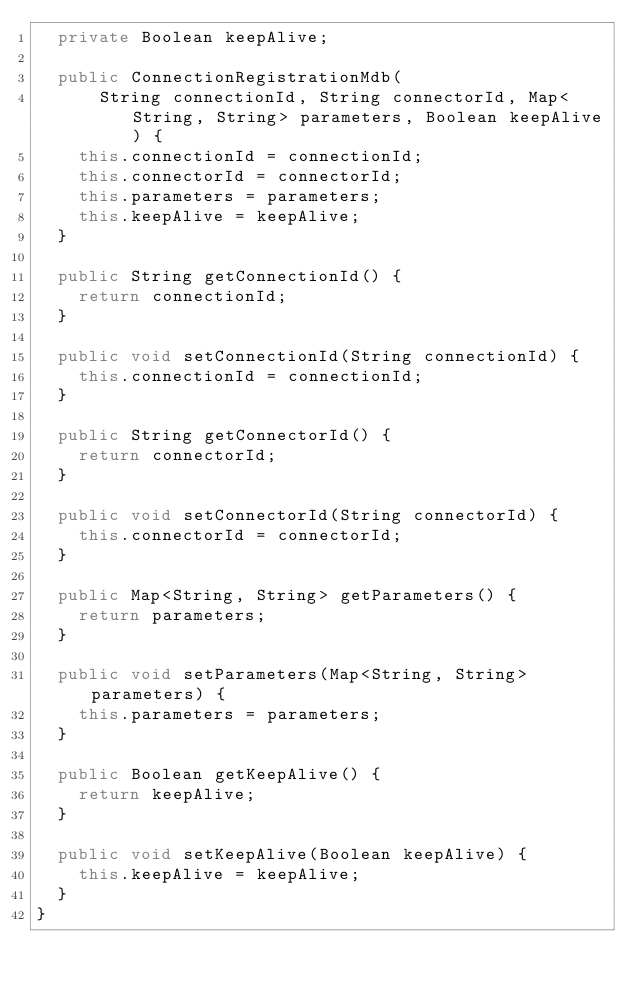Convert code to text. <code><loc_0><loc_0><loc_500><loc_500><_Java_>  private Boolean keepAlive;

  public ConnectionRegistrationMdb(
      String connectionId, String connectorId, Map<String, String> parameters, Boolean keepAlive) {
    this.connectionId = connectionId;
    this.connectorId = connectorId;
    this.parameters = parameters;
    this.keepAlive = keepAlive;
  }

  public String getConnectionId() {
    return connectionId;
  }

  public void setConnectionId(String connectionId) {
    this.connectionId = connectionId;
  }

  public String getConnectorId() {
    return connectorId;
  }

  public void setConnectorId(String connectorId) {
    this.connectorId = connectorId;
  }

  public Map<String, String> getParameters() {
    return parameters;
  }

  public void setParameters(Map<String, String> parameters) {
    this.parameters = parameters;
  }

  public Boolean getKeepAlive() {
    return keepAlive;
  }

  public void setKeepAlive(Boolean keepAlive) {
    this.keepAlive = keepAlive;
  }
}
</code> 